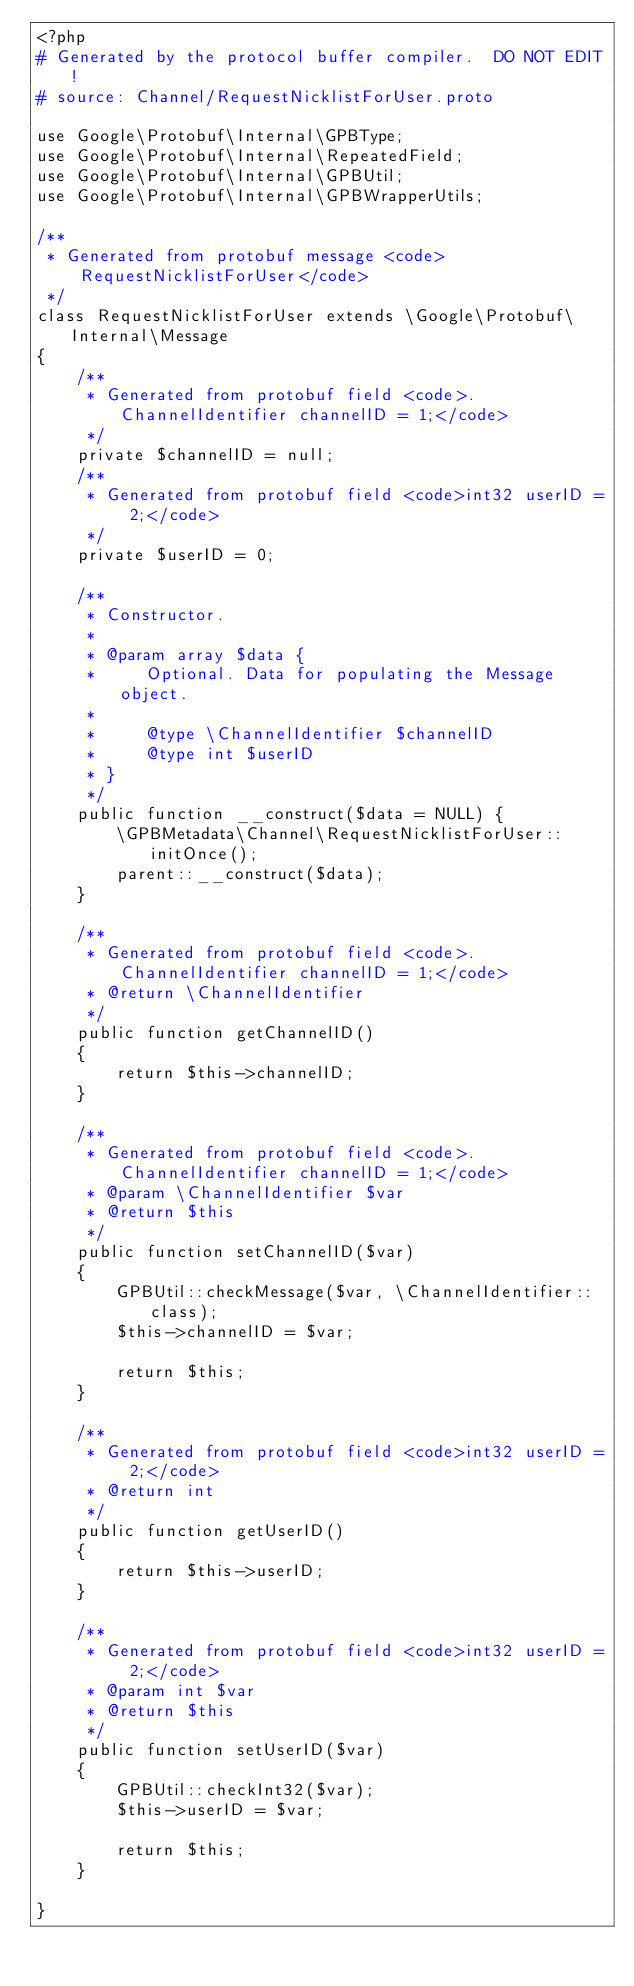Convert code to text. <code><loc_0><loc_0><loc_500><loc_500><_PHP_><?php
# Generated by the protocol buffer compiler.  DO NOT EDIT!
# source: Channel/RequestNicklistForUser.proto

use Google\Protobuf\Internal\GPBType;
use Google\Protobuf\Internal\RepeatedField;
use Google\Protobuf\Internal\GPBUtil;
use Google\Protobuf\Internal\GPBWrapperUtils;

/**
 * Generated from protobuf message <code>RequestNicklistForUser</code>
 */
class RequestNicklistForUser extends \Google\Protobuf\Internal\Message
{
    /**
     * Generated from protobuf field <code>.ChannelIdentifier channelID = 1;</code>
     */
    private $channelID = null;
    /**
     * Generated from protobuf field <code>int32 userID = 2;</code>
     */
    private $userID = 0;

    /**
     * Constructor.
     *
     * @param array $data {
     *     Optional. Data for populating the Message object.
     *
     *     @type \ChannelIdentifier $channelID
     *     @type int $userID
     * }
     */
    public function __construct($data = NULL) {
        \GPBMetadata\Channel\RequestNicklistForUser::initOnce();
        parent::__construct($data);
    }

    /**
     * Generated from protobuf field <code>.ChannelIdentifier channelID = 1;</code>
     * @return \ChannelIdentifier
     */
    public function getChannelID()
    {
        return $this->channelID;
    }

    /**
     * Generated from protobuf field <code>.ChannelIdentifier channelID = 1;</code>
     * @param \ChannelIdentifier $var
     * @return $this
     */
    public function setChannelID($var)
    {
        GPBUtil::checkMessage($var, \ChannelIdentifier::class);
        $this->channelID = $var;

        return $this;
    }

    /**
     * Generated from protobuf field <code>int32 userID = 2;</code>
     * @return int
     */
    public function getUserID()
    {
        return $this->userID;
    }

    /**
     * Generated from protobuf field <code>int32 userID = 2;</code>
     * @param int $var
     * @return $this
     */
    public function setUserID($var)
    {
        GPBUtil::checkInt32($var);
        $this->userID = $var;

        return $this;
    }

}

</code> 